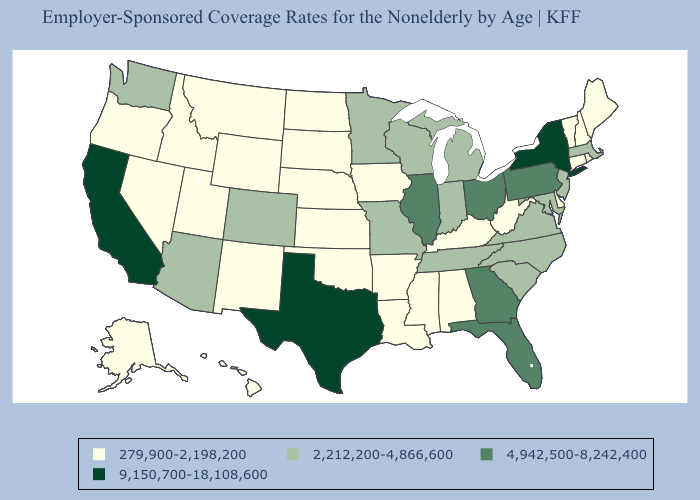Name the states that have a value in the range 9,150,700-18,108,600?
Concise answer only. California, New York, Texas. Does New York have the lowest value in the Northeast?
Keep it brief. No. Name the states that have a value in the range 9,150,700-18,108,600?
Be succinct. California, New York, Texas. What is the value of Massachusetts?
Be succinct. 2,212,200-4,866,600. Which states have the lowest value in the South?
Answer briefly. Alabama, Arkansas, Delaware, Kentucky, Louisiana, Mississippi, Oklahoma, West Virginia. Name the states that have a value in the range 2,212,200-4,866,600?
Quick response, please. Arizona, Colorado, Indiana, Maryland, Massachusetts, Michigan, Minnesota, Missouri, New Jersey, North Carolina, South Carolina, Tennessee, Virginia, Washington, Wisconsin. Does New York have the highest value in the Northeast?
Answer briefly. Yes. Name the states that have a value in the range 9,150,700-18,108,600?
Keep it brief. California, New York, Texas. Does Mississippi have the lowest value in the USA?
Give a very brief answer. Yes. What is the highest value in states that border Tennessee?
Give a very brief answer. 4,942,500-8,242,400. Does Hawaii have the same value as Nevada?
Quick response, please. Yes. Does the map have missing data?
Write a very short answer. No. What is the lowest value in states that border West Virginia?
Short answer required. 279,900-2,198,200. What is the value of South Dakota?
Keep it brief. 279,900-2,198,200. What is the highest value in states that border South Carolina?
Concise answer only. 4,942,500-8,242,400. 